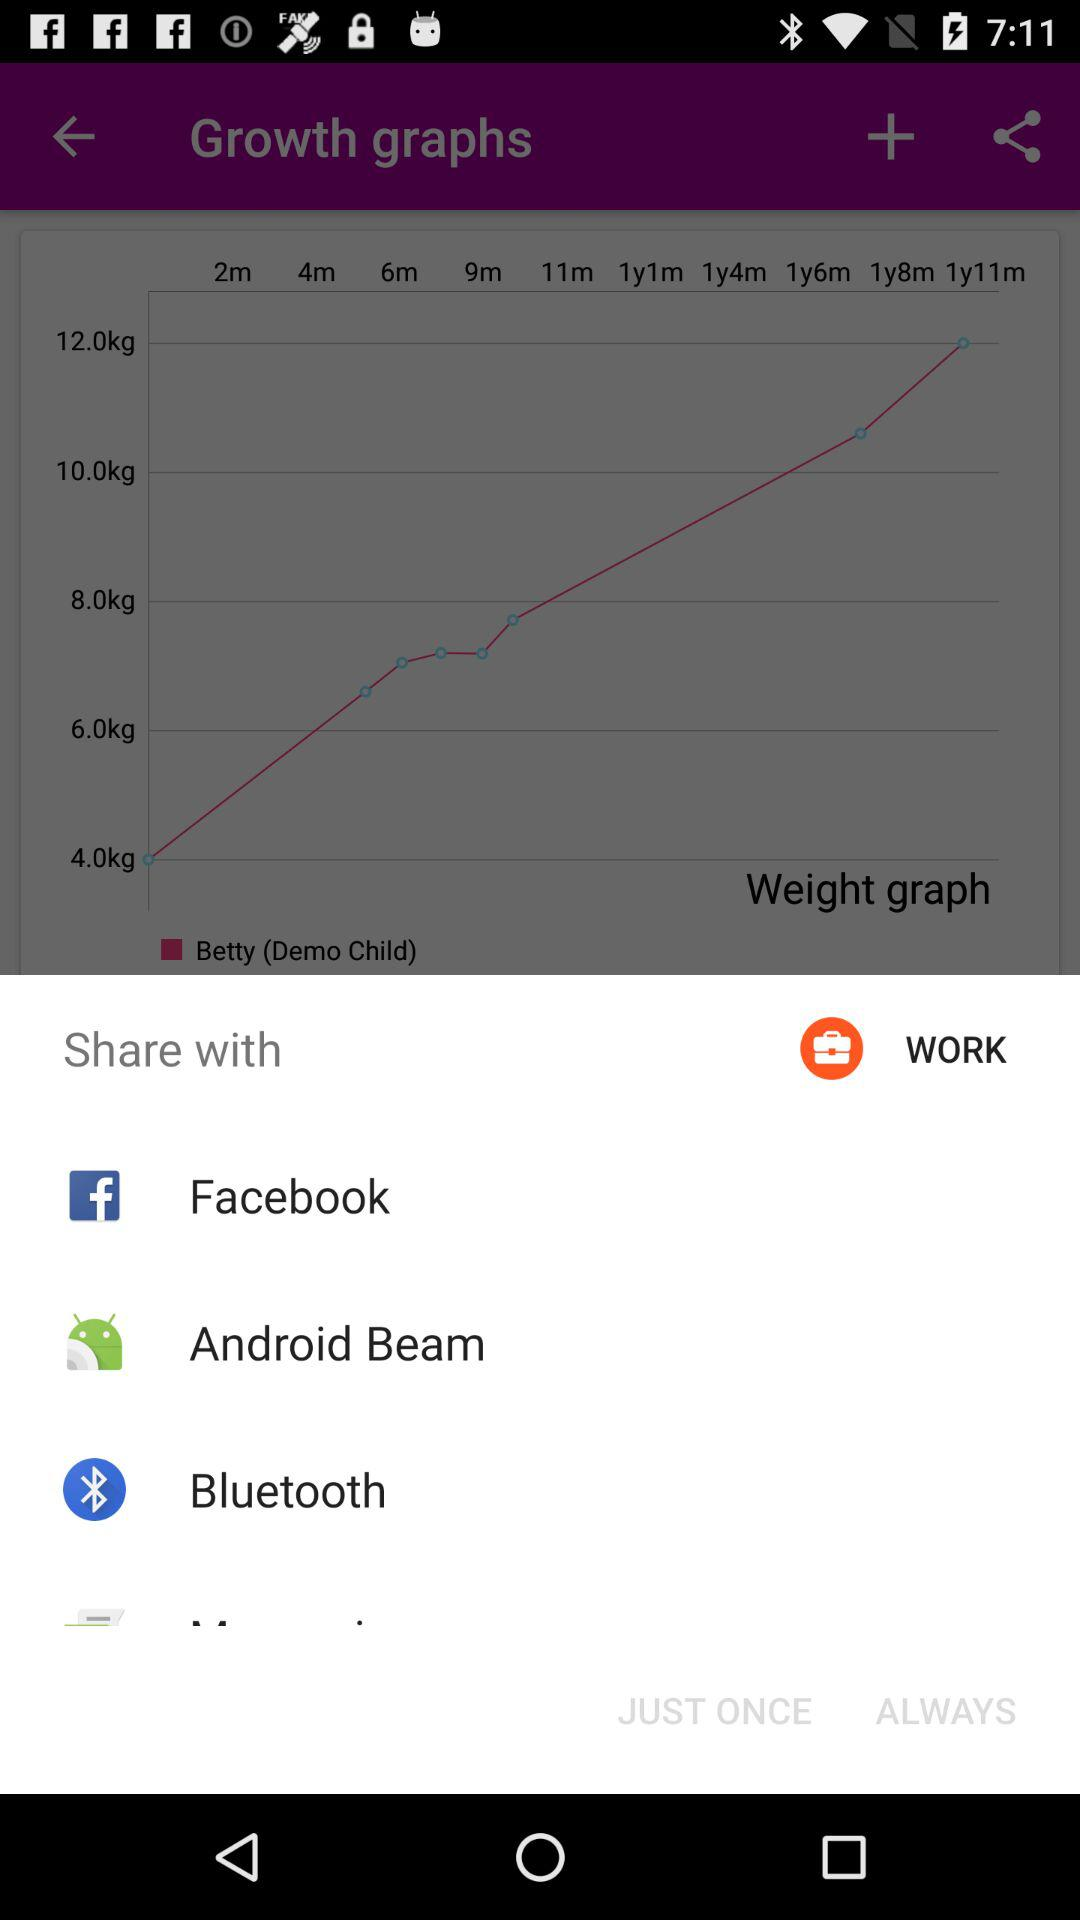Which app is available for sharing? The available apps for sharing are "Facebook", "Android Beam" and "Bluetooth". 